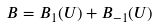Convert formula to latex. <formula><loc_0><loc_0><loc_500><loc_500>B = B _ { 1 } ( U ) + B _ { - 1 } ( U )</formula> 